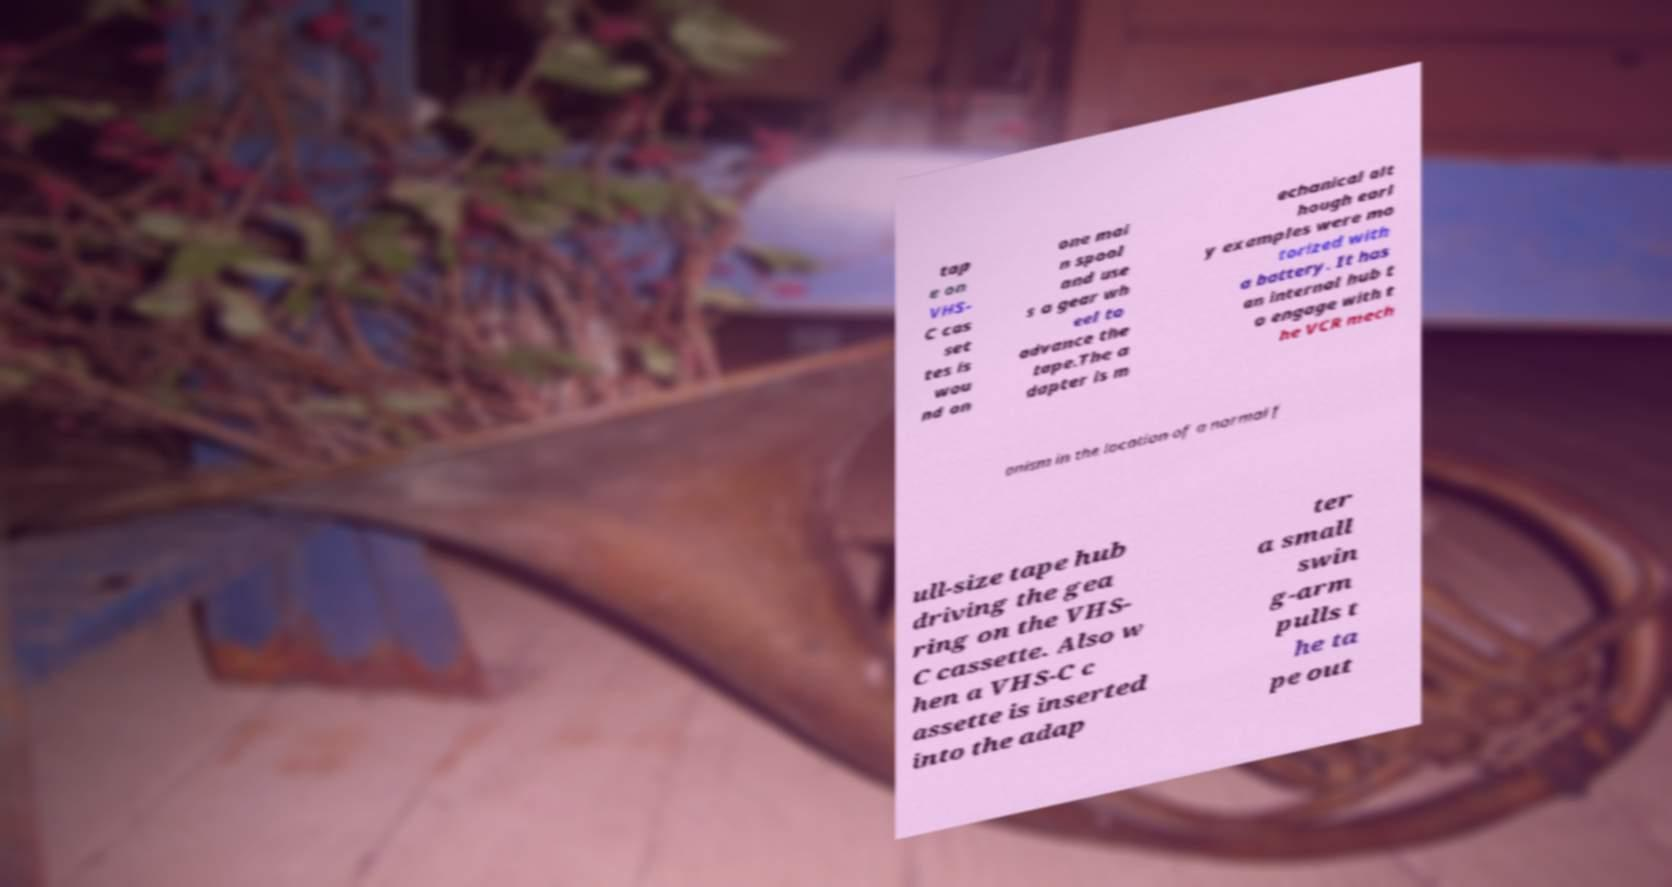Please identify and transcribe the text found in this image. tap e on VHS- C cas set tes is wou nd on one mai n spool and use s a gear wh eel to advance the tape.The a dapter is m echanical alt hough earl y examples were mo torized with a battery. It has an internal hub t o engage with t he VCR mech anism in the location of a normal f ull-size tape hub driving the gea ring on the VHS- C cassette. Also w hen a VHS-C c assette is inserted into the adap ter a small swin g-arm pulls t he ta pe out 